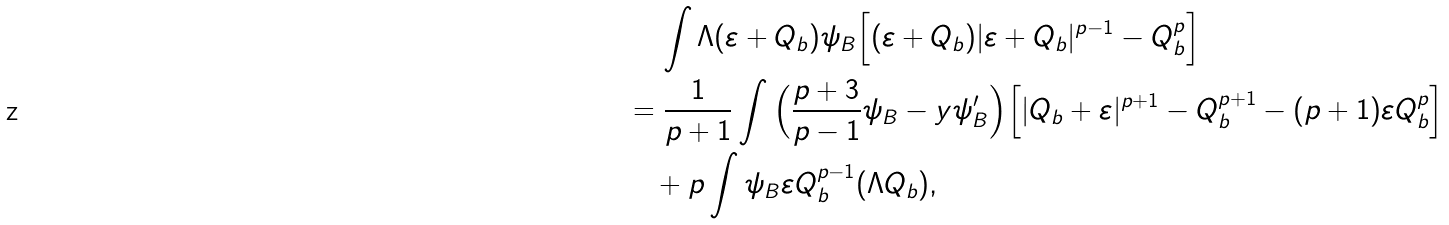<formula> <loc_0><loc_0><loc_500><loc_500>& \quad \, \int \Lambda ( \varepsilon + Q _ { b } ) \psi _ { B } \Big { [ } ( \varepsilon + Q _ { b } ) | \varepsilon + Q _ { b } | ^ { p - 1 } - Q _ { b } ^ { p } \Big { ] } \\ & = \frac { 1 } { p + 1 } \int \Big { ( } \frac { p + 3 } { p - 1 } \psi _ { B } - y \psi ^ { \prime } _ { B } \Big { ) } \Big { [ } | Q _ { b } + \varepsilon | ^ { p + 1 } - Q _ { b } ^ { p + 1 } - ( p + 1 ) \varepsilon Q _ { b } ^ { p } \Big { ] } \\ & \quad + p \int \psi _ { B } \varepsilon Q _ { b } ^ { p - 1 } ( \Lambda Q _ { b } ) ,</formula> 